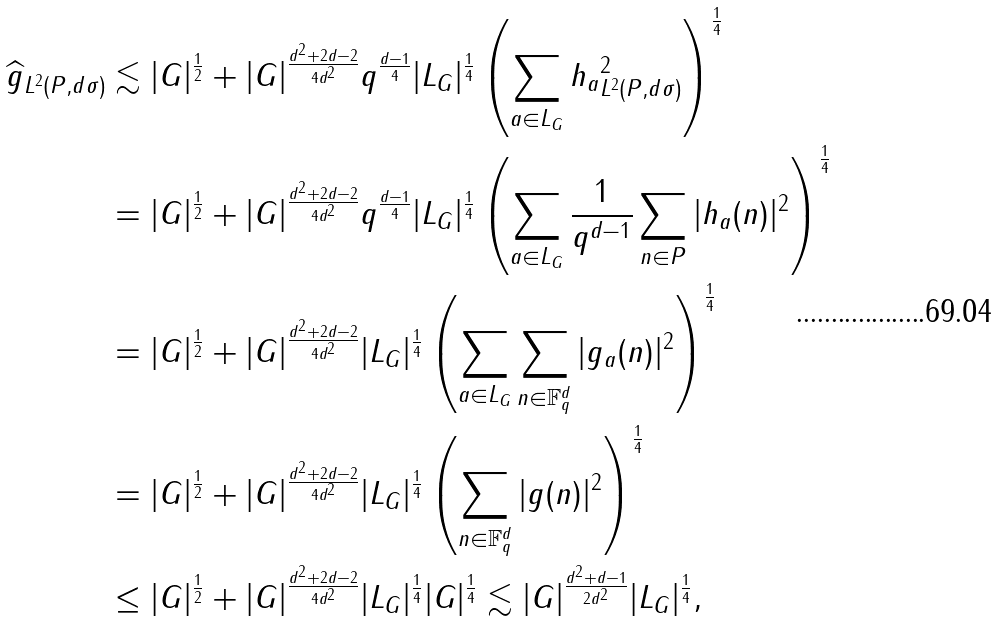<formula> <loc_0><loc_0><loc_500><loc_500>\| \widehat { g } \| _ { L ^ { 2 } ( P , d \sigma ) } & \lesssim | G | ^ { \frac { 1 } { 2 } } + | G | ^ { \frac { d ^ { 2 } + 2 d - 2 } { 4 d ^ { 2 } } } q ^ { \frac { d - 1 } { 4 } } | L _ { G } | ^ { \frac { 1 } { 4 } } \left ( \sum _ { a \in L _ { G } } \| h _ { a } \| ^ { 2 } _ { L ^ { 2 } ( P , d \sigma ) } \right ) ^ { \frac { 1 } { 4 } } \\ & = | G | ^ { \frac { 1 } { 2 } } + | G | ^ { \frac { d ^ { 2 } + 2 d - 2 } { 4 d ^ { 2 } } } q ^ { \frac { d - 1 } { 4 } } | L _ { G } | ^ { \frac { 1 } { 4 } } \left ( \sum _ { a \in L _ { G } } \frac { 1 } { q ^ { d - 1 } } \sum _ { n \in P } | h _ { a } ( n ) | ^ { 2 } \right ) ^ { \frac { 1 } { 4 } } \\ & = | G | ^ { \frac { 1 } { 2 } } + | G | ^ { \frac { d ^ { 2 } + 2 d - 2 } { 4 d ^ { 2 } } } | L _ { G } | ^ { \frac { 1 } { 4 } } \left ( \sum _ { a \in L _ { G } } \sum _ { n \in \mathbb { F } _ { q } ^ { d } } | g _ { a } ( n ) | ^ { 2 } \right ) ^ { \frac { 1 } { 4 } } \\ & = | G | ^ { \frac { 1 } { 2 } } + | G | ^ { \frac { d ^ { 2 } + 2 d - 2 } { 4 d ^ { 2 } } } | L _ { G } | ^ { \frac { 1 } { 4 } } \left ( \sum _ { n \in \mathbb { F } _ { q } ^ { d } } | g ( n ) | ^ { 2 } \right ) ^ { \frac { 1 } { 4 } } \\ & \leq | G | ^ { \frac { 1 } { 2 } } + | G | ^ { \frac { d ^ { 2 } + 2 d - 2 } { 4 d ^ { 2 } } } | L _ { G } | ^ { \frac { 1 } { 4 } } | G | ^ { \frac { 1 } { 4 } } \lesssim | G | ^ { \frac { d ^ { 2 } + d - 1 } { 2 d ^ { 2 } } } | L _ { G } | ^ { \frac { 1 } { 4 } } ,</formula> 